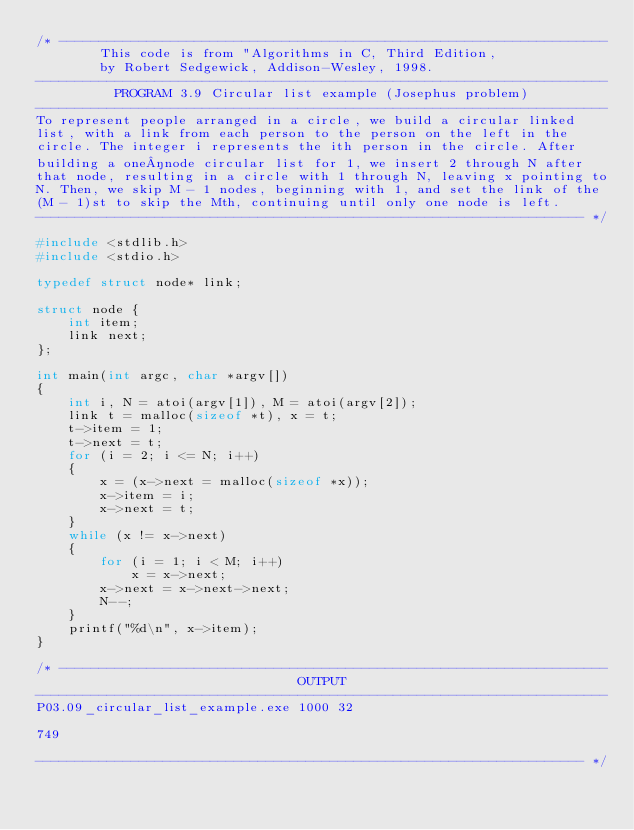<code> <loc_0><loc_0><loc_500><loc_500><_C_>/* ---------------------------------------------------------------------
        This code is from "Algorithms in C, Third Edition,
        by Robert Sedgewick, Addison-Wesley, 1998.
------------------------------------------------------------------------
          PROGRAM 3.9 Circular list example (Josephus problem)
------------------------------------------------------------------------
To represent people arranged in a circle, we build a circular linked
list, with a link from each person to the person on the left in the
circle. The integer i represents the ith person in the circle. After
building a one­node circular list for 1, we insert 2 through N after
that node, resulting in a circle with 1 through N, leaving x pointing to
N. Then, we skip M - 1 nodes, beginning with 1, and set the link of the
(M - 1)st to skip the Mth, continuing until only one node is left.
--------------------------------------------------------------------- */

#include <stdlib.h>
#include <stdio.h>

typedef struct node* link;

struct node {
    int item;
    link next;
};

int main(int argc, char *argv[])
{
    int i, N = atoi(argv[1]), M = atoi(argv[2]);
    link t = malloc(sizeof *t), x = t;
    t->item = 1;
    t->next = t;
    for (i = 2; i <= N; i++)
    {
        x = (x->next = malloc(sizeof *x));
        x->item = i;
        x->next = t;
    }
    while (x != x->next)
    {
        for (i = 1; i < M; i++)
            x = x->next;
        x->next = x->next->next;
        N--;
    }
    printf("%d\n", x->item);
}

/* ---------------------------------------------------------------------
                                 OUTPUT
------------------------------------------------------------------------
P03.09_circular_list_example.exe 1000 32

749

--------------------------------------------------------------------- */
</code> 